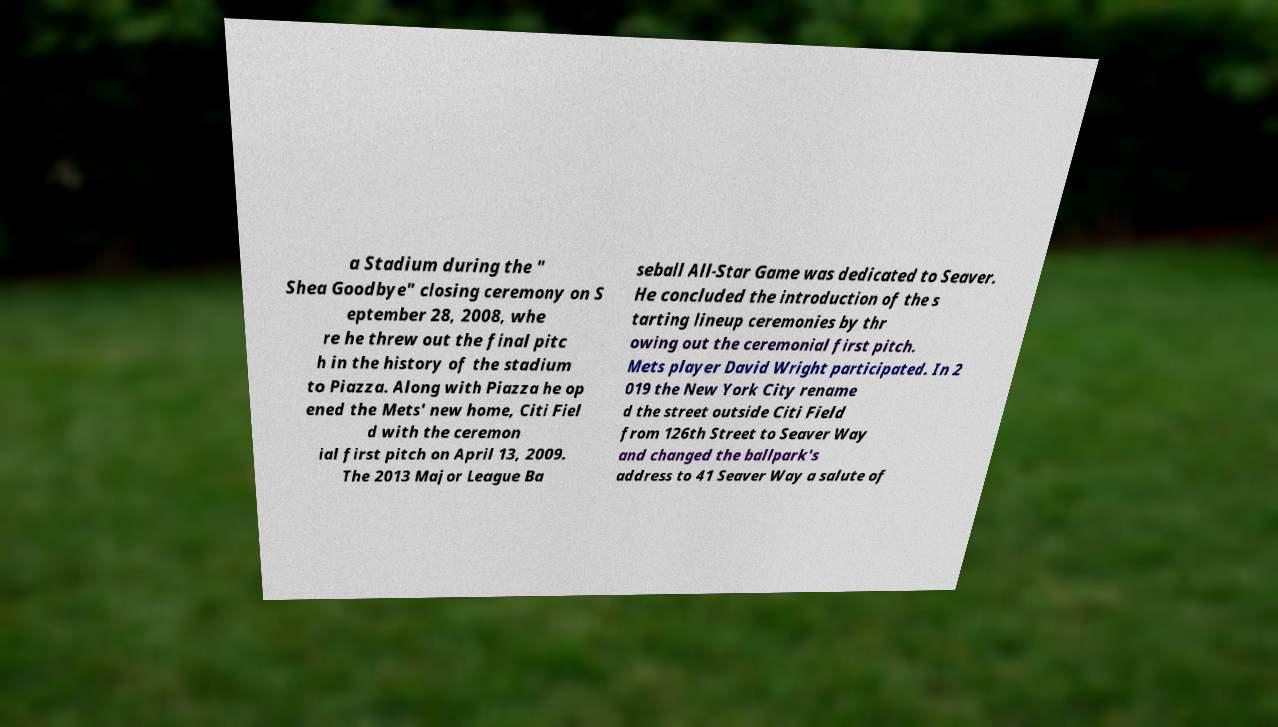I need the written content from this picture converted into text. Can you do that? a Stadium during the " Shea Goodbye" closing ceremony on S eptember 28, 2008, whe re he threw out the final pitc h in the history of the stadium to Piazza. Along with Piazza he op ened the Mets' new home, Citi Fiel d with the ceremon ial first pitch on April 13, 2009. The 2013 Major League Ba seball All-Star Game was dedicated to Seaver. He concluded the introduction of the s tarting lineup ceremonies by thr owing out the ceremonial first pitch. Mets player David Wright participated. In 2 019 the New York City rename d the street outside Citi Field from 126th Street to Seaver Way and changed the ballpark's address to 41 Seaver Way a salute of 